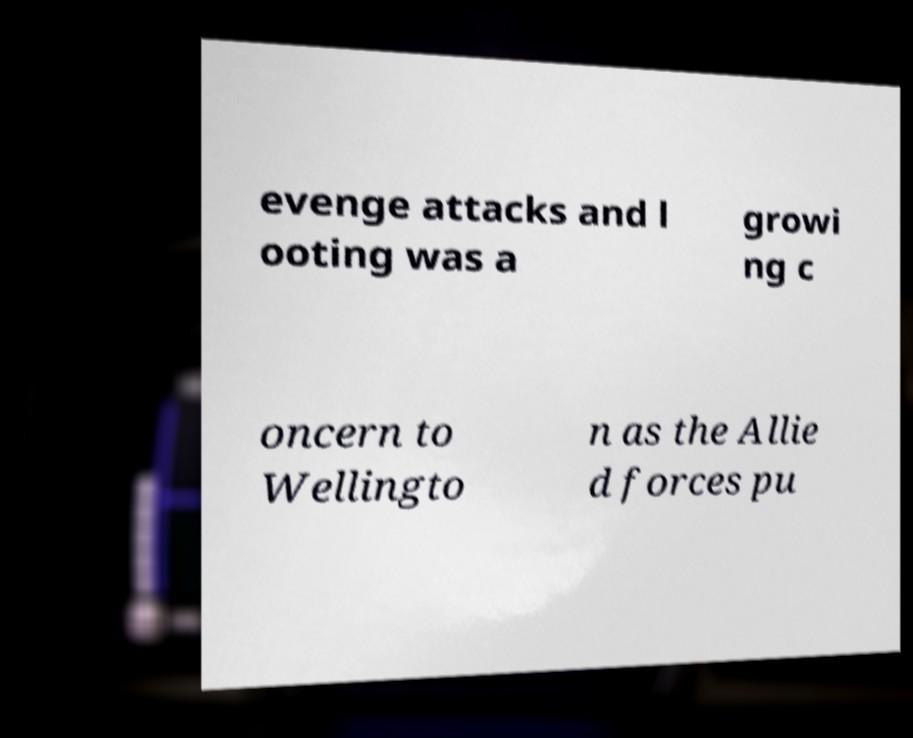I need the written content from this picture converted into text. Can you do that? evenge attacks and l ooting was a growi ng c oncern to Wellingto n as the Allie d forces pu 